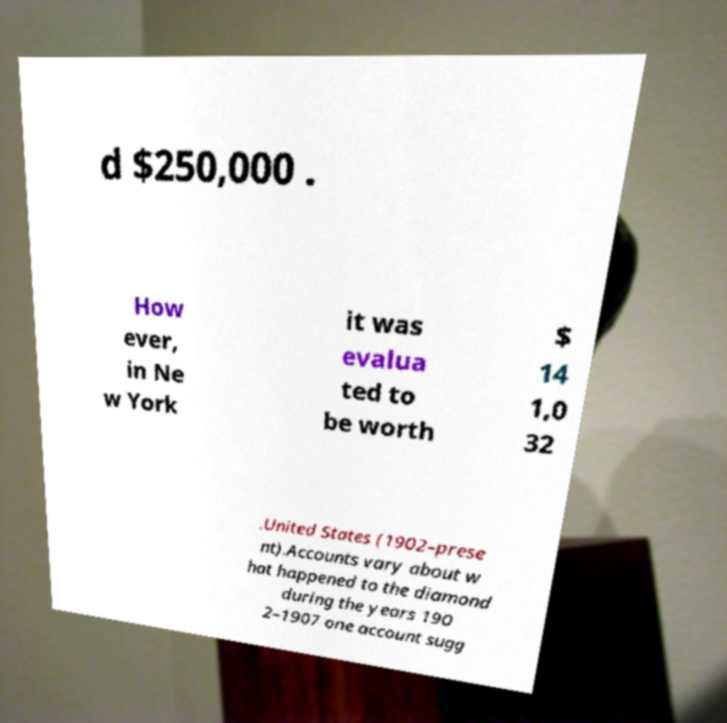Can you accurately transcribe the text from the provided image for me? d $250,000 . How ever, in Ne w York it was evalua ted to be worth $ 14 1,0 32 .United States (1902–prese nt).Accounts vary about w hat happened to the diamond during the years 190 2–1907 one account sugg 